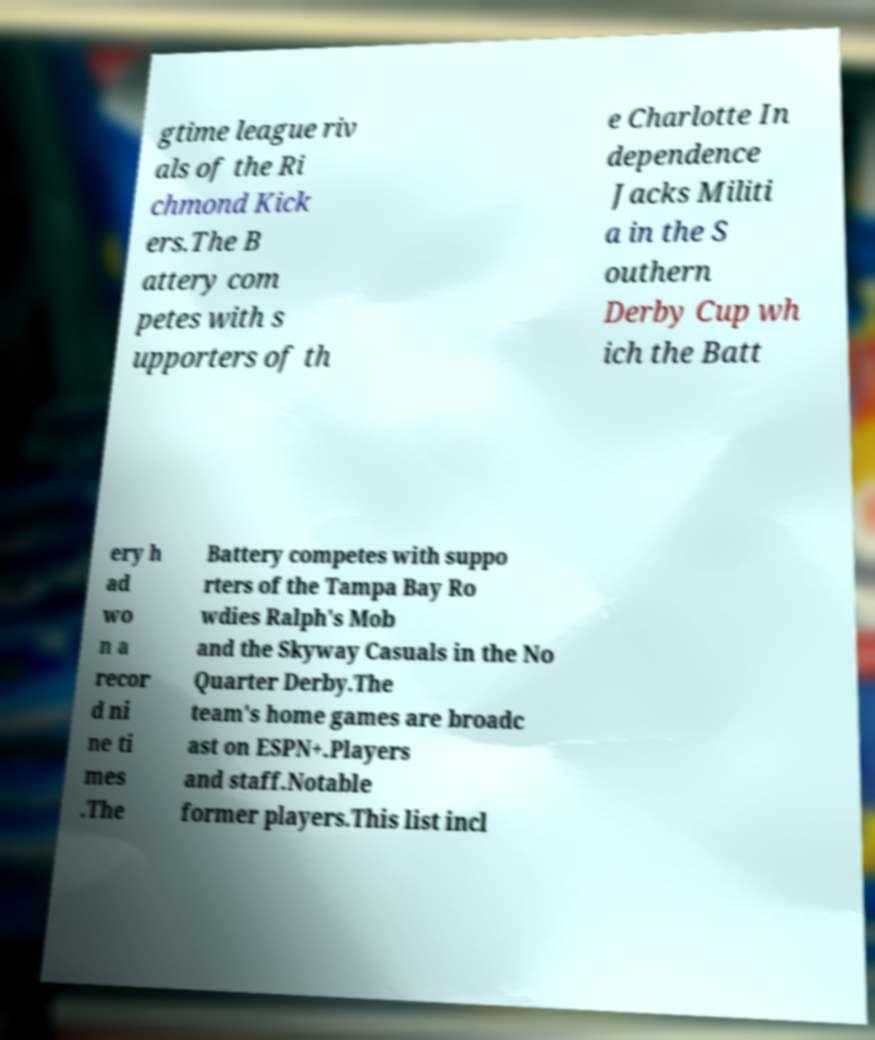What messages or text are displayed in this image? I need them in a readable, typed format. gtime league riv als of the Ri chmond Kick ers.The B attery com petes with s upporters of th e Charlotte In dependence Jacks Militi a in the S outhern Derby Cup wh ich the Batt ery h ad wo n a recor d ni ne ti mes .The Battery competes with suppo rters of the Tampa Bay Ro wdies Ralph's Mob and the Skyway Casuals in the No Quarter Derby.The team's home games are broadc ast on ESPN+.Players and staff.Notable former players.This list incl 